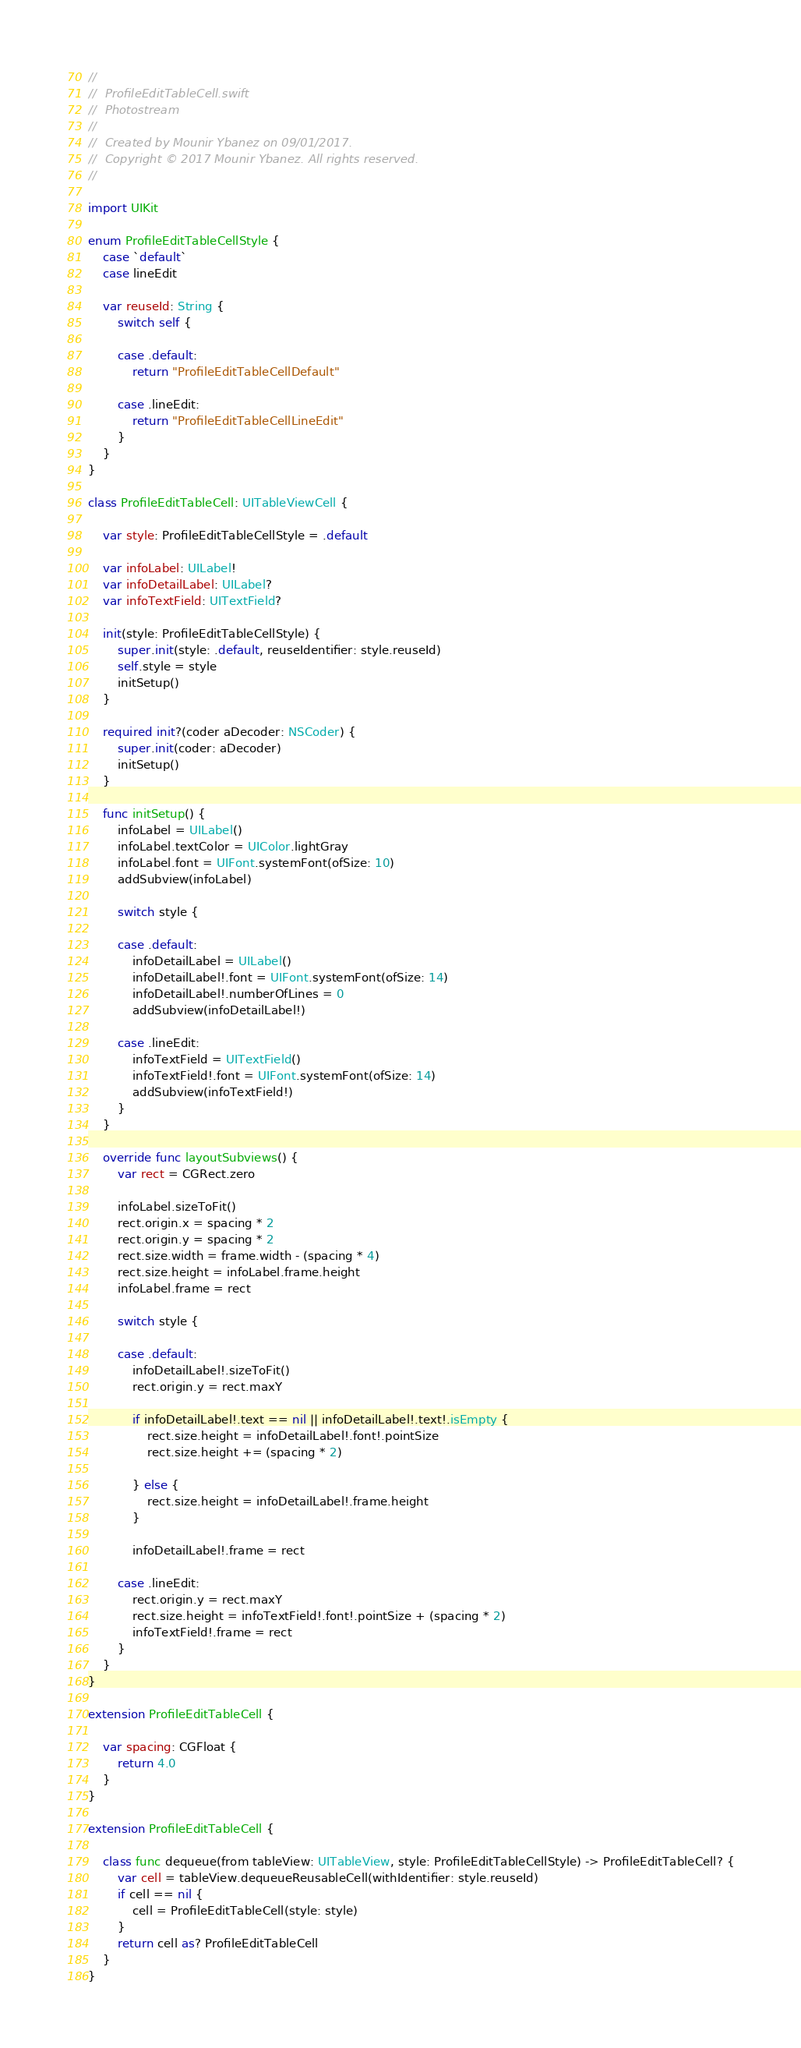Convert code to text. <code><loc_0><loc_0><loc_500><loc_500><_Swift_>//
//  ProfileEditTableCell.swift
//  Photostream
//
//  Created by Mounir Ybanez on 09/01/2017.
//  Copyright © 2017 Mounir Ybanez. All rights reserved.
//

import UIKit

enum ProfileEditTableCellStyle {
    case `default`
    case lineEdit
    
    var reuseId: String {
        switch self {
            
        case .default:
            return "ProfileEditTableCellDefault"
            
        case .lineEdit:
            return "ProfileEditTableCellLineEdit"
        }
    }
}

class ProfileEditTableCell: UITableViewCell {

    var style: ProfileEditTableCellStyle = .default
    
    var infoLabel: UILabel!
    var infoDetailLabel: UILabel?
    var infoTextField: UITextField?
    
    init(style: ProfileEditTableCellStyle) {
        super.init(style: .default, reuseIdentifier: style.reuseId)
        self.style = style
        initSetup()
    }
    
    required init?(coder aDecoder: NSCoder) {
        super.init(coder: aDecoder)
        initSetup()
    }
    
    func initSetup() {
        infoLabel = UILabel()
        infoLabel.textColor = UIColor.lightGray
        infoLabel.font = UIFont.systemFont(ofSize: 10)
        addSubview(infoLabel)
        
        switch style {
            
        case .default:
            infoDetailLabel = UILabel()
            infoDetailLabel!.font = UIFont.systemFont(ofSize: 14)
            infoDetailLabel!.numberOfLines = 0
            addSubview(infoDetailLabel!)
            
        case .lineEdit:
            infoTextField = UITextField()
            infoTextField!.font = UIFont.systemFont(ofSize: 14)
            addSubview(infoTextField!)
        }
    }
    
    override func layoutSubviews() {
        var rect = CGRect.zero
        
        infoLabel.sizeToFit()
        rect.origin.x = spacing * 2
        rect.origin.y = spacing * 2
        rect.size.width = frame.width - (spacing * 4)
        rect.size.height = infoLabel.frame.height
        infoLabel.frame = rect
        
        switch style {
        
        case .default:
            infoDetailLabel!.sizeToFit()
            rect.origin.y = rect.maxY
            
            if infoDetailLabel!.text == nil || infoDetailLabel!.text!.isEmpty {
                rect.size.height = infoDetailLabel!.font!.pointSize
                rect.size.height += (spacing * 2)
                
            } else {
                rect.size.height = infoDetailLabel!.frame.height
            }
            
            infoDetailLabel!.frame = rect
            
        case .lineEdit:
            rect.origin.y = rect.maxY
            rect.size.height = infoTextField!.font!.pointSize + (spacing * 2)
            infoTextField!.frame = rect
        }
    }
}

extension ProfileEditTableCell {
    
    var spacing: CGFloat {
        return 4.0
    }
}

extension ProfileEditTableCell {
    
    class func dequeue(from tableView: UITableView, style: ProfileEditTableCellStyle) -> ProfileEditTableCell? {
        var cell = tableView.dequeueReusableCell(withIdentifier: style.reuseId)
        if cell == nil {
            cell = ProfileEditTableCell(style: style)
        }
        return cell as? ProfileEditTableCell
    }
}
</code> 